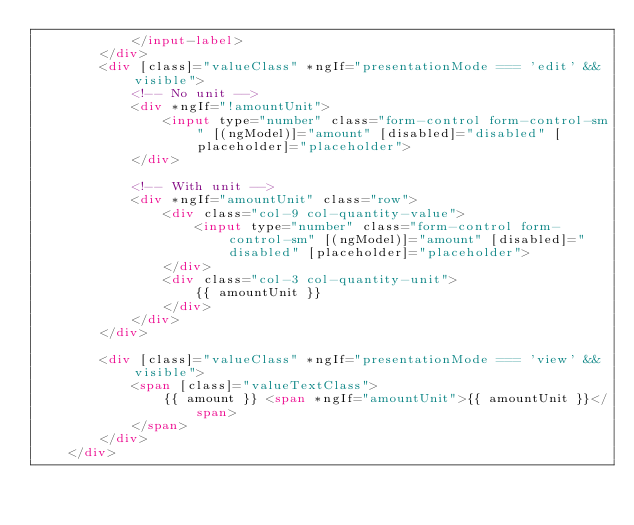<code> <loc_0><loc_0><loc_500><loc_500><_HTML_>            </input-label>
        </div>
        <div [class]="valueClass" *ngIf="presentationMode === 'edit' && visible">
            <!-- No unit -->
            <div *ngIf="!amountUnit">
                <input type="number" class="form-control form-control-sm" [(ngModel)]="amount" [disabled]="disabled" [placeholder]="placeholder">
            </div>

            <!-- With unit -->
            <div *ngIf="amountUnit" class="row">
                <div class="col-9 col-quantity-value">
                    <input type="number" class="form-control form-control-sm" [(ngModel)]="amount" [disabled]="disabled" [placeholder]="placeholder">
                </div>
                <div class="col-3 col-quantity-unit">
                    {{ amountUnit }}
                </div>
            </div>
        </div>

        <div [class]="valueClass" *ngIf="presentationMode === 'view' && visible">
            <span [class]="valueTextClass">
                {{ amount }} <span *ngIf="amountUnit">{{ amountUnit }}</span>
            </span>
        </div>
    </div>
</code> 